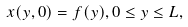<formula> <loc_0><loc_0><loc_500><loc_500>x ( y , 0 ) = f ( y ) , 0 \leq y \leq L ,</formula> 